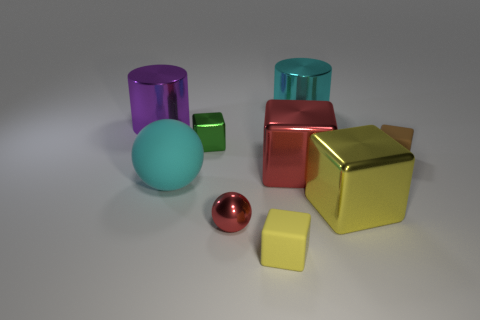What is the size of the green thing?
Offer a very short reply. Small. Do the brown object and the cylinder behind the purple object have the same size?
Keep it short and to the point. No. There is a metal cube on the left side of the yellow block on the left side of the cyan object that is right of the big cyan matte thing; what is its color?
Offer a very short reply. Green. Do the tiny thing on the right side of the large cyan cylinder and the large cyan cylinder have the same material?
Keep it short and to the point. No. What number of other objects are the same material as the cyan cylinder?
Your answer should be compact. 5. What material is the brown cube that is the same size as the green block?
Provide a short and direct response. Rubber. Do the yellow thing left of the cyan metallic thing and the small metal object in front of the brown matte object have the same shape?
Your answer should be compact. No. There is a green metallic object that is the same size as the brown matte thing; what is its shape?
Give a very brief answer. Cube. Do the sphere that is behind the red metallic ball and the cyan object that is behind the red block have the same material?
Offer a terse response. No. There is a yellow object that is on the right side of the cyan cylinder; are there any small red balls to the left of it?
Make the answer very short. Yes. 